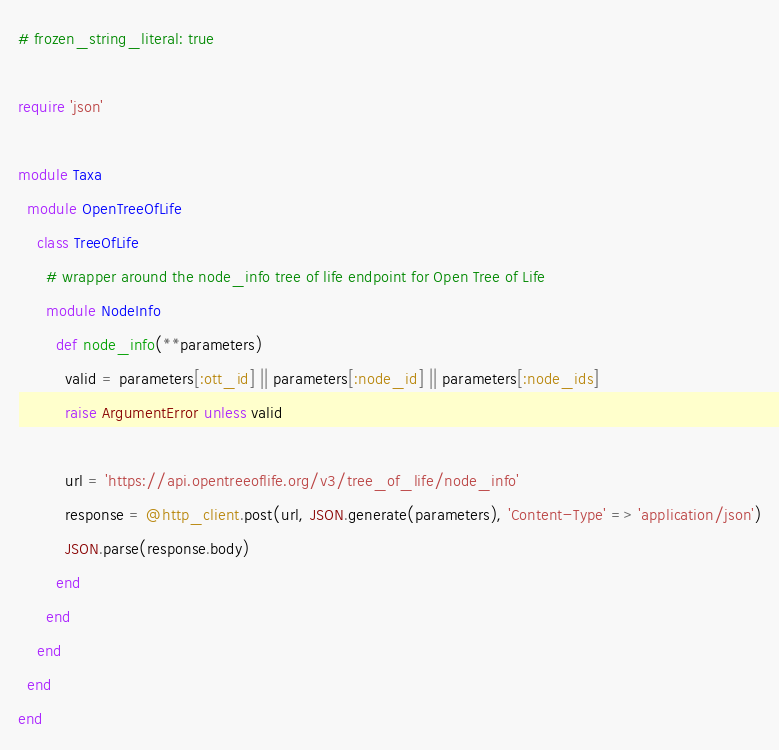Convert code to text. <code><loc_0><loc_0><loc_500><loc_500><_Ruby_># frozen_string_literal: true

require 'json'

module Taxa
  module OpenTreeOfLife
    class TreeOfLife
      # wrapper around the node_info tree of life endpoint for Open Tree of Life
      module NodeInfo
        def node_info(**parameters)
          valid = parameters[:ott_id] || parameters[:node_id] || parameters[:node_ids]
          raise ArgumentError unless valid

          url = 'https://api.opentreeoflife.org/v3/tree_of_life/node_info'
          response = @http_client.post(url, JSON.generate(parameters), 'Content-Type' => 'application/json')
          JSON.parse(response.body)
        end
      end
    end
  end
end
</code> 